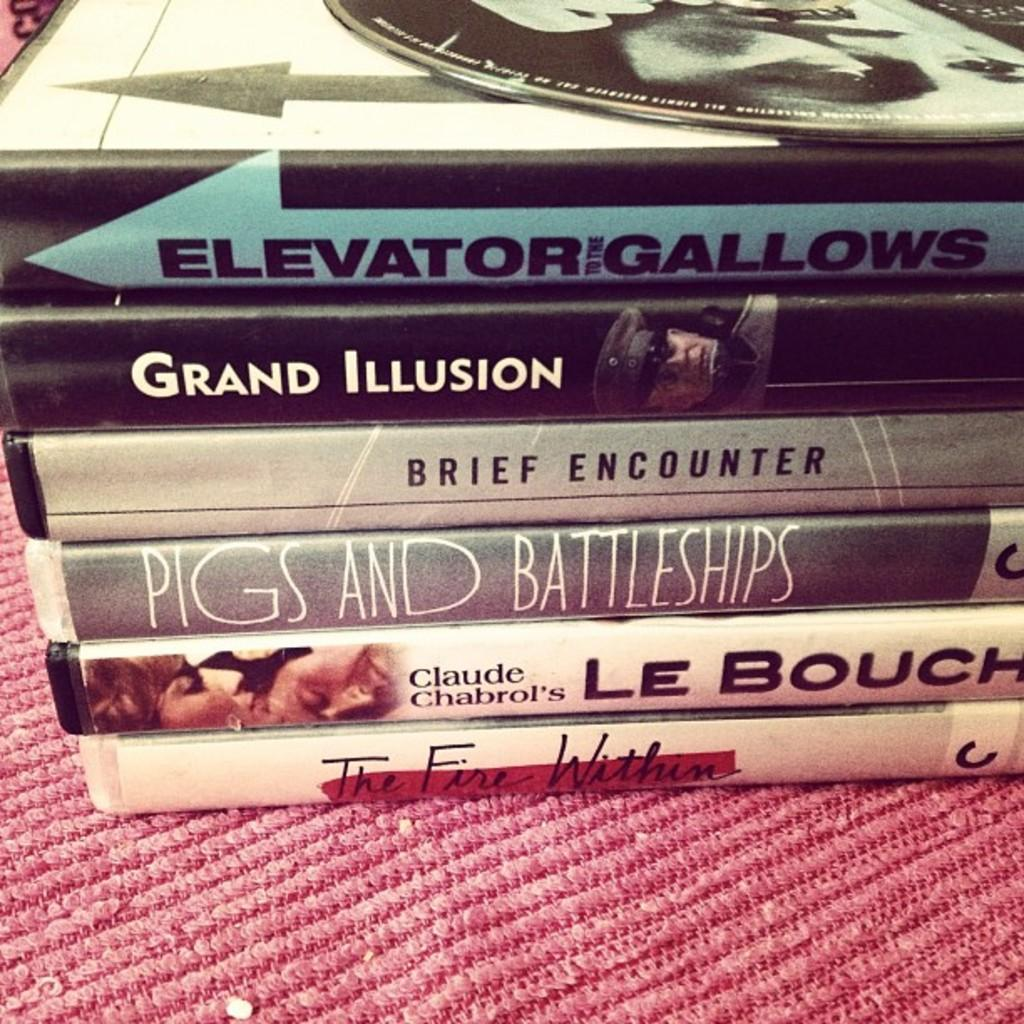<image>
Give a short and clear explanation of the subsequent image. A stack of videotape cases includes titles like Pigs and Battleships, Grand Illusion and The Fire Within. 